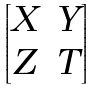Convert formula to latex. <formula><loc_0><loc_0><loc_500><loc_500>\begin{bmatrix} X & Y \\ Z & T \end{bmatrix}</formula> 